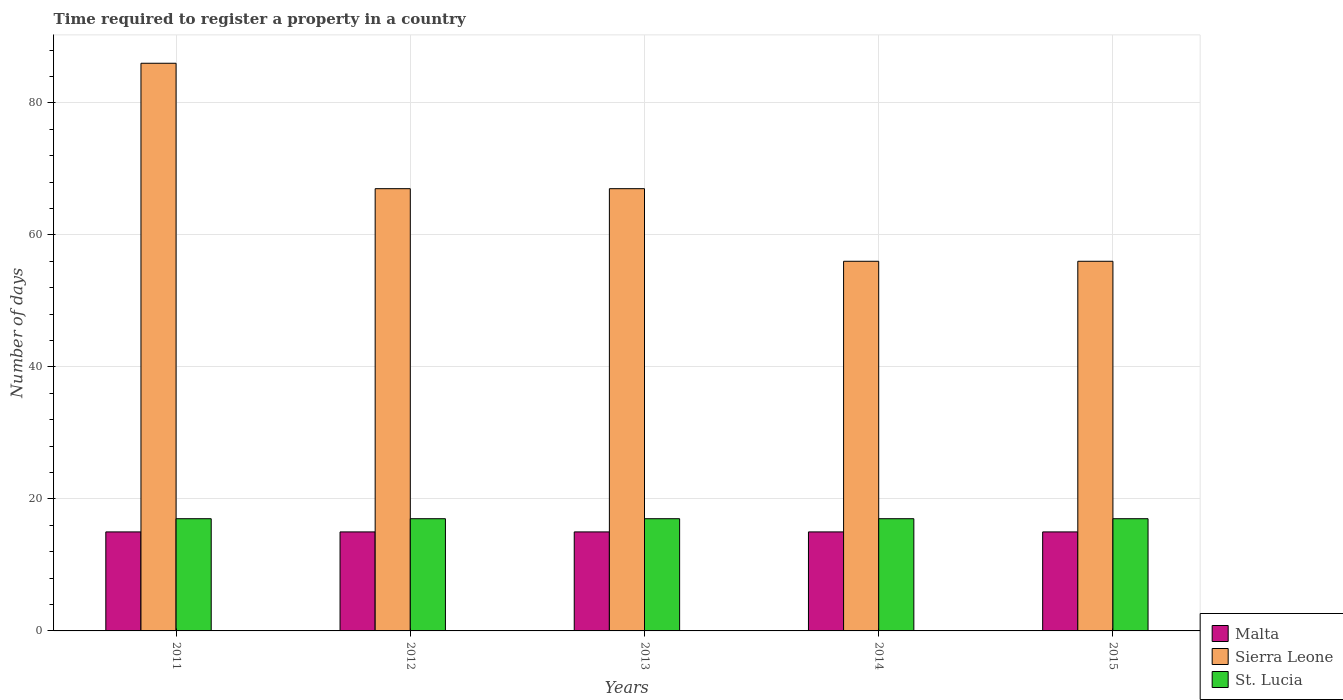Are the number of bars per tick equal to the number of legend labels?
Your response must be concise. Yes. How many bars are there on the 1st tick from the right?
Ensure brevity in your answer.  3. Across all years, what is the maximum number of days required to register a property in Malta?
Give a very brief answer. 15. Across all years, what is the minimum number of days required to register a property in Sierra Leone?
Provide a short and direct response. 56. In which year was the number of days required to register a property in Malta minimum?
Give a very brief answer. 2011. What is the total number of days required to register a property in Sierra Leone in the graph?
Keep it short and to the point. 332. What is the difference between the number of days required to register a property in Sierra Leone in 2014 and the number of days required to register a property in Malta in 2013?
Your response must be concise. 41. What is the average number of days required to register a property in St. Lucia per year?
Keep it short and to the point. 17. In the year 2014, what is the difference between the number of days required to register a property in Malta and number of days required to register a property in St. Lucia?
Keep it short and to the point. -2. What is the ratio of the number of days required to register a property in Malta in 2014 to that in 2015?
Provide a short and direct response. 1. Is the number of days required to register a property in Malta in 2011 less than that in 2013?
Offer a terse response. No. Is the difference between the number of days required to register a property in Malta in 2011 and 2014 greater than the difference between the number of days required to register a property in St. Lucia in 2011 and 2014?
Keep it short and to the point. No. What is the difference between the highest and the lowest number of days required to register a property in St. Lucia?
Your response must be concise. 0. What does the 2nd bar from the left in 2015 represents?
Provide a succinct answer. Sierra Leone. What does the 1st bar from the right in 2012 represents?
Your response must be concise. St. Lucia. Is it the case that in every year, the sum of the number of days required to register a property in Sierra Leone and number of days required to register a property in St. Lucia is greater than the number of days required to register a property in Malta?
Provide a short and direct response. Yes. Are the values on the major ticks of Y-axis written in scientific E-notation?
Give a very brief answer. No. Does the graph contain any zero values?
Offer a very short reply. No. Does the graph contain grids?
Ensure brevity in your answer.  Yes. How many legend labels are there?
Your answer should be very brief. 3. What is the title of the graph?
Provide a short and direct response. Time required to register a property in a country. Does "South Sudan" appear as one of the legend labels in the graph?
Give a very brief answer. No. What is the label or title of the X-axis?
Offer a terse response. Years. What is the label or title of the Y-axis?
Offer a very short reply. Number of days. What is the Number of days in Sierra Leone in 2011?
Give a very brief answer. 86. What is the Number of days of St. Lucia in 2012?
Offer a terse response. 17. What is the Number of days in Malta in 2013?
Offer a terse response. 15. What is the Number of days in St. Lucia in 2013?
Provide a succinct answer. 17. What is the Number of days in Malta in 2014?
Keep it short and to the point. 15. What is the Number of days in Sierra Leone in 2014?
Offer a very short reply. 56. What is the Number of days of St. Lucia in 2014?
Your response must be concise. 17. Across all years, what is the maximum Number of days in Sierra Leone?
Provide a short and direct response. 86. Across all years, what is the maximum Number of days of St. Lucia?
Give a very brief answer. 17. Across all years, what is the minimum Number of days of Malta?
Give a very brief answer. 15. Across all years, what is the minimum Number of days in Sierra Leone?
Ensure brevity in your answer.  56. What is the total Number of days of Sierra Leone in the graph?
Ensure brevity in your answer.  332. What is the total Number of days in St. Lucia in the graph?
Your answer should be very brief. 85. What is the difference between the Number of days of Malta in 2011 and that in 2012?
Give a very brief answer. 0. What is the difference between the Number of days in Sierra Leone in 2011 and that in 2012?
Your response must be concise. 19. What is the difference between the Number of days in Malta in 2011 and that in 2013?
Offer a very short reply. 0. What is the difference between the Number of days in Sierra Leone in 2011 and that in 2013?
Offer a very short reply. 19. What is the difference between the Number of days in St. Lucia in 2011 and that in 2014?
Keep it short and to the point. 0. What is the difference between the Number of days in Sierra Leone in 2012 and that in 2014?
Ensure brevity in your answer.  11. What is the difference between the Number of days of Malta in 2012 and that in 2015?
Provide a short and direct response. 0. What is the difference between the Number of days of Sierra Leone in 2013 and that in 2015?
Give a very brief answer. 11. What is the difference between the Number of days in Malta in 2014 and that in 2015?
Ensure brevity in your answer.  0. What is the difference between the Number of days in Sierra Leone in 2014 and that in 2015?
Your answer should be very brief. 0. What is the difference between the Number of days of Malta in 2011 and the Number of days of Sierra Leone in 2012?
Offer a terse response. -52. What is the difference between the Number of days in Malta in 2011 and the Number of days in St. Lucia in 2012?
Provide a short and direct response. -2. What is the difference between the Number of days of Malta in 2011 and the Number of days of Sierra Leone in 2013?
Offer a very short reply. -52. What is the difference between the Number of days of Malta in 2011 and the Number of days of St. Lucia in 2013?
Make the answer very short. -2. What is the difference between the Number of days of Malta in 2011 and the Number of days of Sierra Leone in 2014?
Offer a very short reply. -41. What is the difference between the Number of days in Malta in 2011 and the Number of days in St. Lucia in 2014?
Your answer should be very brief. -2. What is the difference between the Number of days in Malta in 2011 and the Number of days in Sierra Leone in 2015?
Provide a succinct answer. -41. What is the difference between the Number of days of Malta in 2011 and the Number of days of St. Lucia in 2015?
Make the answer very short. -2. What is the difference between the Number of days in Malta in 2012 and the Number of days in Sierra Leone in 2013?
Offer a very short reply. -52. What is the difference between the Number of days of Malta in 2012 and the Number of days of St. Lucia in 2013?
Give a very brief answer. -2. What is the difference between the Number of days in Sierra Leone in 2012 and the Number of days in St. Lucia in 2013?
Give a very brief answer. 50. What is the difference between the Number of days of Malta in 2012 and the Number of days of Sierra Leone in 2014?
Your answer should be very brief. -41. What is the difference between the Number of days in Malta in 2012 and the Number of days in St. Lucia in 2014?
Provide a short and direct response. -2. What is the difference between the Number of days in Malta in 2012 and the Number of days in Sierra Leone in 2015?
Your answer should be compact. -41. What is the difference between the Number of days of Malta in 2012 and the Number of days of St. Lucia in 2015?
Offer a very short reply. -2. What is the difference between the Number of days in Malta in 2013 and the Number of days in Sierra Leone in 2014?
Provide a short and direct response. -41. What is the difference between the Number of days in Malta in 2013 and the Number of days in Sierra Leone in 2015?
Your answer should be very brief. -41. What is the difference between the Number of days of Malta in 2013 and the Number of days of St. Lucia in 2015?
Your response must be concise. -2. What is the difference between the Number of days of Malta in 2014 and the Number of days of Sierra Leone in 2015?
Offer a very short reply. -41. What is the difference between the Number of days in Malta in 2014 and the Number of days in St. Lucia in 2015?
Offer a terse response. -2. What is the difference between the Number of days in Sierra Leone in 2014 and the Number of days in St. Lucia in 2015?
Give a very brief answer. 39. What is the average Number of days in Malta per year?
Make the answer very short. 15. What is the average Number of days of Sierra Leone per year?
Offer a very short reply. 66.4. What is the average Number of days in St. Lucia per year?
Provide a short and direct response. 17. In the year 2011, what is the difference between the Number of days of Malta and Number of days of Sierra Leone?
Offer a very short reply. -71. In the year 2011, what is the difference between the Number of days in Malta and Number of days in St. Lucia?
Keep it short and to the point. -2. In the year 2011, what is the difference between the Number of days in Sierra Leone and Number of days in St. Lucia?
Offer a very short reply. 69. In the year 2012, what is the difference between the Number of days in Malta and Number of days in Sierra Leone?
Offer a terse response. -52. In the year 2013, what is the difference between the Number of days of Malta and Number of days of Sierra Leone?
Keep it short and to the point. -52. In the year 2013, what is the difference between the Number of days in Malta and Number of days in St. Lucia?
Your response must be concise. -2. In the year 2014, what is the difference between the Number of days in Malta and Number of days in Sierra Leone?
Your answer should be compact. -41. In the year 2014, what is the difference between the Number of days of Sierra Leone and Number of days of St. Lucia?
Provide a short and direct response. 39. In the year 2015, what is the difference between the Number of days of Malta and Number of days of Sierra Leone?
Give a very brief answer. -41. In the year 2015, what is the difference between the Number of days in Malta and Number of days in St. Lucia?
Provide a succinct answer. -2. What is the ratio of the Number of days in Malta in 2011 to that in 2012?
Make the answer very short. 1. What is the ratio of the Number of days in Sierra Leone in 2011 to that in 2012?
Keep it short and to the point. 1.28. What is the ratio of the Number of days in Sierra Leone in 2011 to that in 2013?
Offer a terse response. 1.28. What is the ratio of the Number of days in Sierra Leone in 2011 to that in 2014?
Your answer should be very brief. 1.54. What is the ratio of the Number of days in St. Lucia in 2011 to that in 2014?
Your answer should be very brief. 1. What is the ratio of the Number of days in Sierra Leone in 2011 to that in 2015?
Ensure brevity in your answer.  1.54. What is the ratio of the Number of days in Malta in 2012 to that in 2013?
Your answer should be very brief. 1. What is the ratio of the Number of days in Sierra Leone in 2012 to that in 2014?
Give a very brief answer. 1.2. What is the ratio of the Number of days in St. Lucia in 2012 to that in 2014?
Give a very brief answer. 1. What is the ratio of the Number of days in Malta in 2012 to that in 2015?
Ensure brevity in your answer.  1. What is the ratio of the Number of days in Sierra Leone in 2012 to that in 2015?
Your answer should be very brief. 1.2. What is the ratio of the Number of days in St. Lucia in 2012 to that in 2015?
Offer a very short reply. 1. What is the ratio of the Number of days of Malta in 2013 to that in 2014?
Offer a very short reply. 1. What is the ratio of the Number of days in Sierra Leone in 2013 to that in 2014?
Your answer should be compact. 1.2. What is the ratio of the Number of days in Malta in 2013 to that in 2015?
Offer a very short reply. 1. What is the ratio of the Number of days of Sierra Leone in 2013 to that in 2015?
Provide a succinct answer. 1.2. What is the ratio of the Number of days of St. Lucia in 2013 to that in 2015?
Your answer should be very brief. 1. What is the ratio of the Number of days of Sierra Leone in 2014 to that in 2015?
Your response must be concise. 1. What is the difference between the highest and the second highest Number of days in St. Lucia?
Offer a very short reply. 0. What is the difference between the highest and the lowest Number of days of Malta?
Make the answer very short. 0. What is the difference between the highest and the lowest Number of days of Sierra Leone?
Provide a succinct answer. 30. What is the difference between the highest and the lowest Number of days in St. Lucia?
Your response must be concise. 0. 